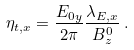<formula> <loc_0><loc_0><loc_500><loc_500>\eta _ { t , x } = \frac { E _ { 0 y } } { 2 \pi } \frac { \lambda _ { E , x } } { B _ { z } ^ { 0 } } \, .</formula> 